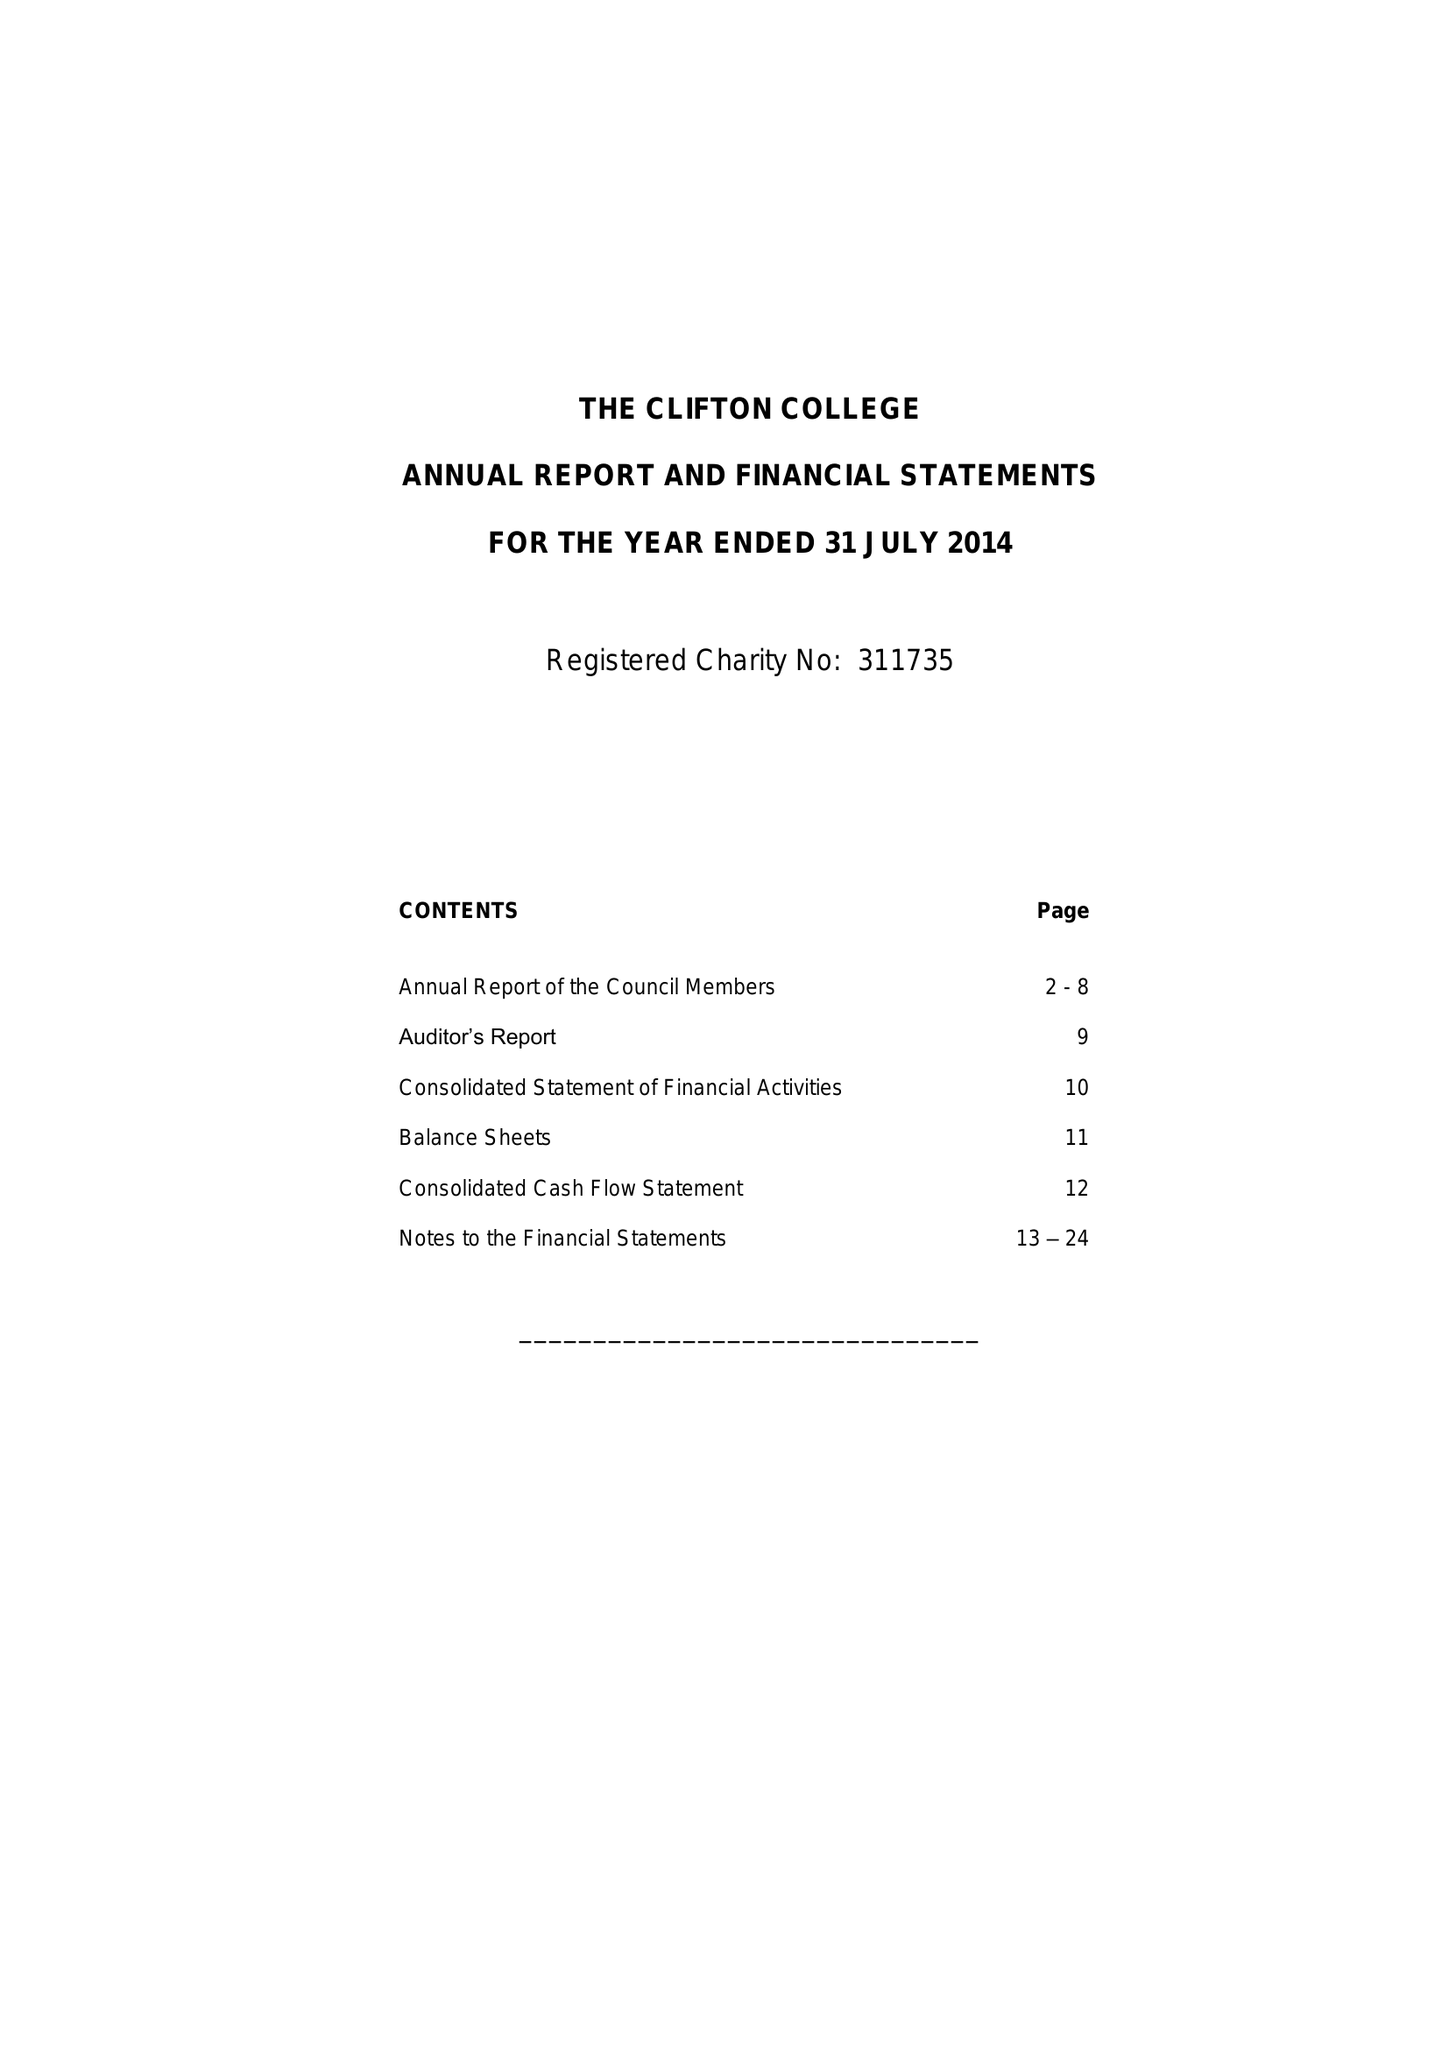What is the value for the address__street_line?
Answer the question using a single word or phrase. 32 COLLEGE ROAD 